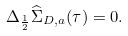Convert formula to latex. <formula><loc_0><loc_0><loc_500><loc_500>\Delta _ { \frac { 1 } { 2 } } \widehat { \Sigma } _ { D , a } ( \tau ) = 0 .</formula> 